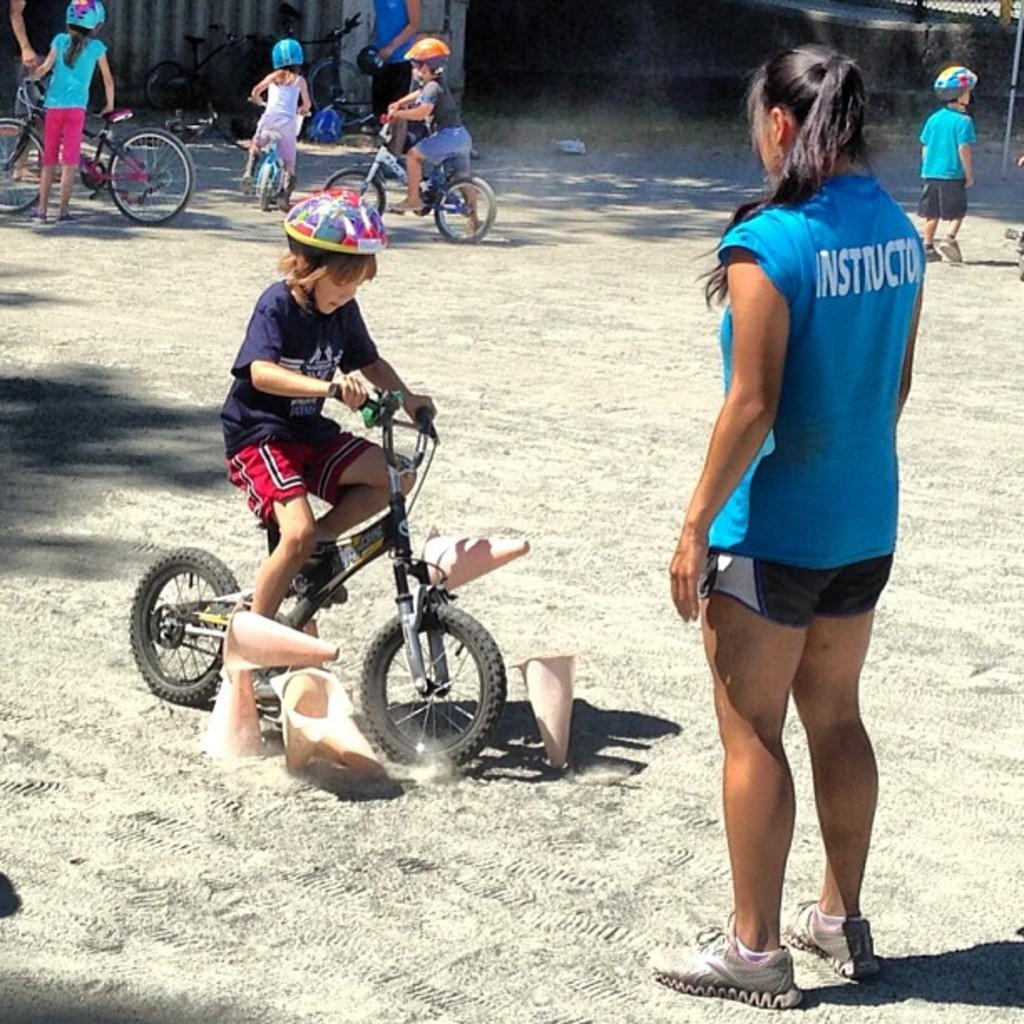What activity are the kids engaged in the image? The kids are riding a bicycle in the image. What safety precaution are the kids taking while riding the bicycle? The kids are wearing helmets while riding the bicycle. What is the position of one of the kids in relation to the bicycle? One kid is standing beside his bicycle and holding it. Who else is present in the image besides the kids? A woman is standing in front of the bicycle. What type of animals can be seen in the zoo in the image? There is no zoo present in the image; it features kids riding a bicycle and a woman standing nearby. 